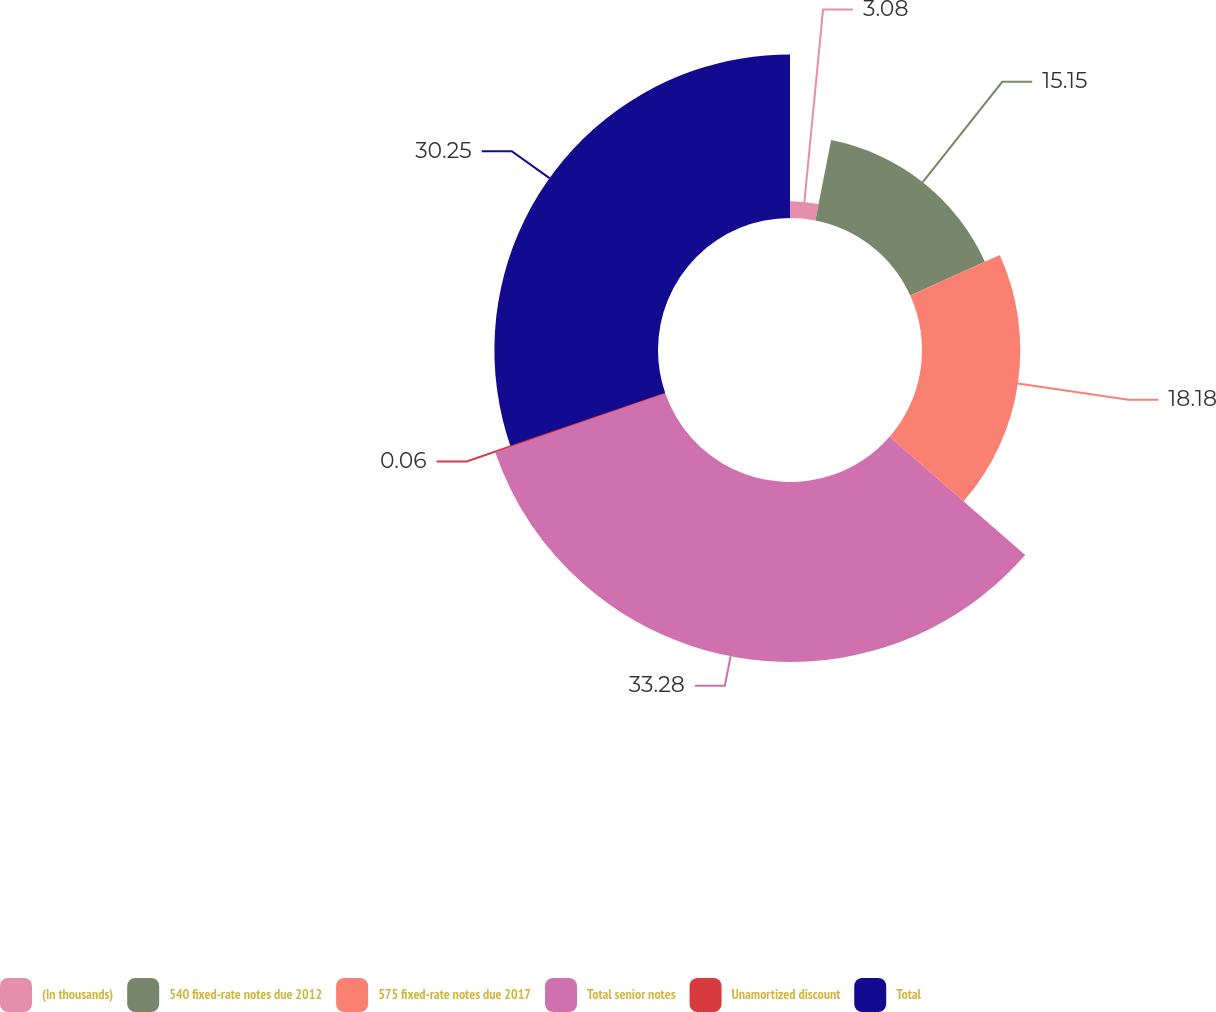<chart> <loc_0><loc_0><loc_500><loc_500><pie_chart><fcel>(In thousands)<fcel>540 fixed-rate notes due 2012<fcel>575 fixed-rate notes due 2017<fcel>Total senior notes<fcel>Unamortized discount<fcel>Total<nl><fcel>3.08%<fcel>15.15%<fcel>18.18%<fcel>33.28%<fcel>0.06%<fcel>30.25%<nl></chart> 